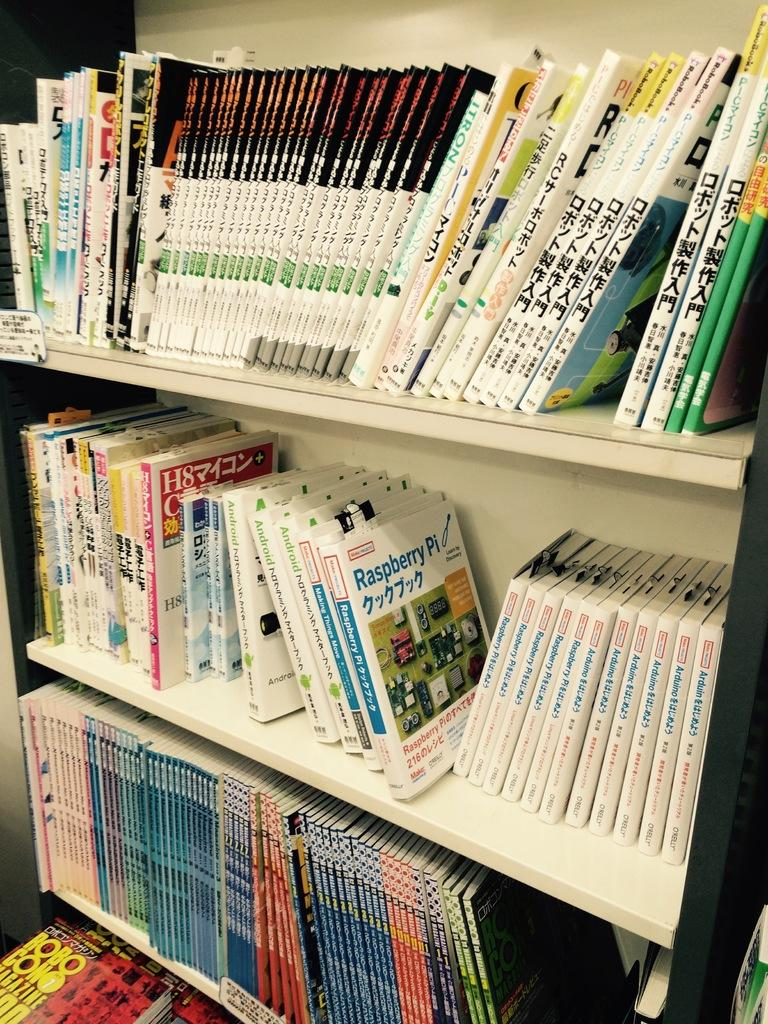Provide a one-sentence caption for the provided image. A manual for the Raspberry Pi sits on the shelf with many other manuals. 